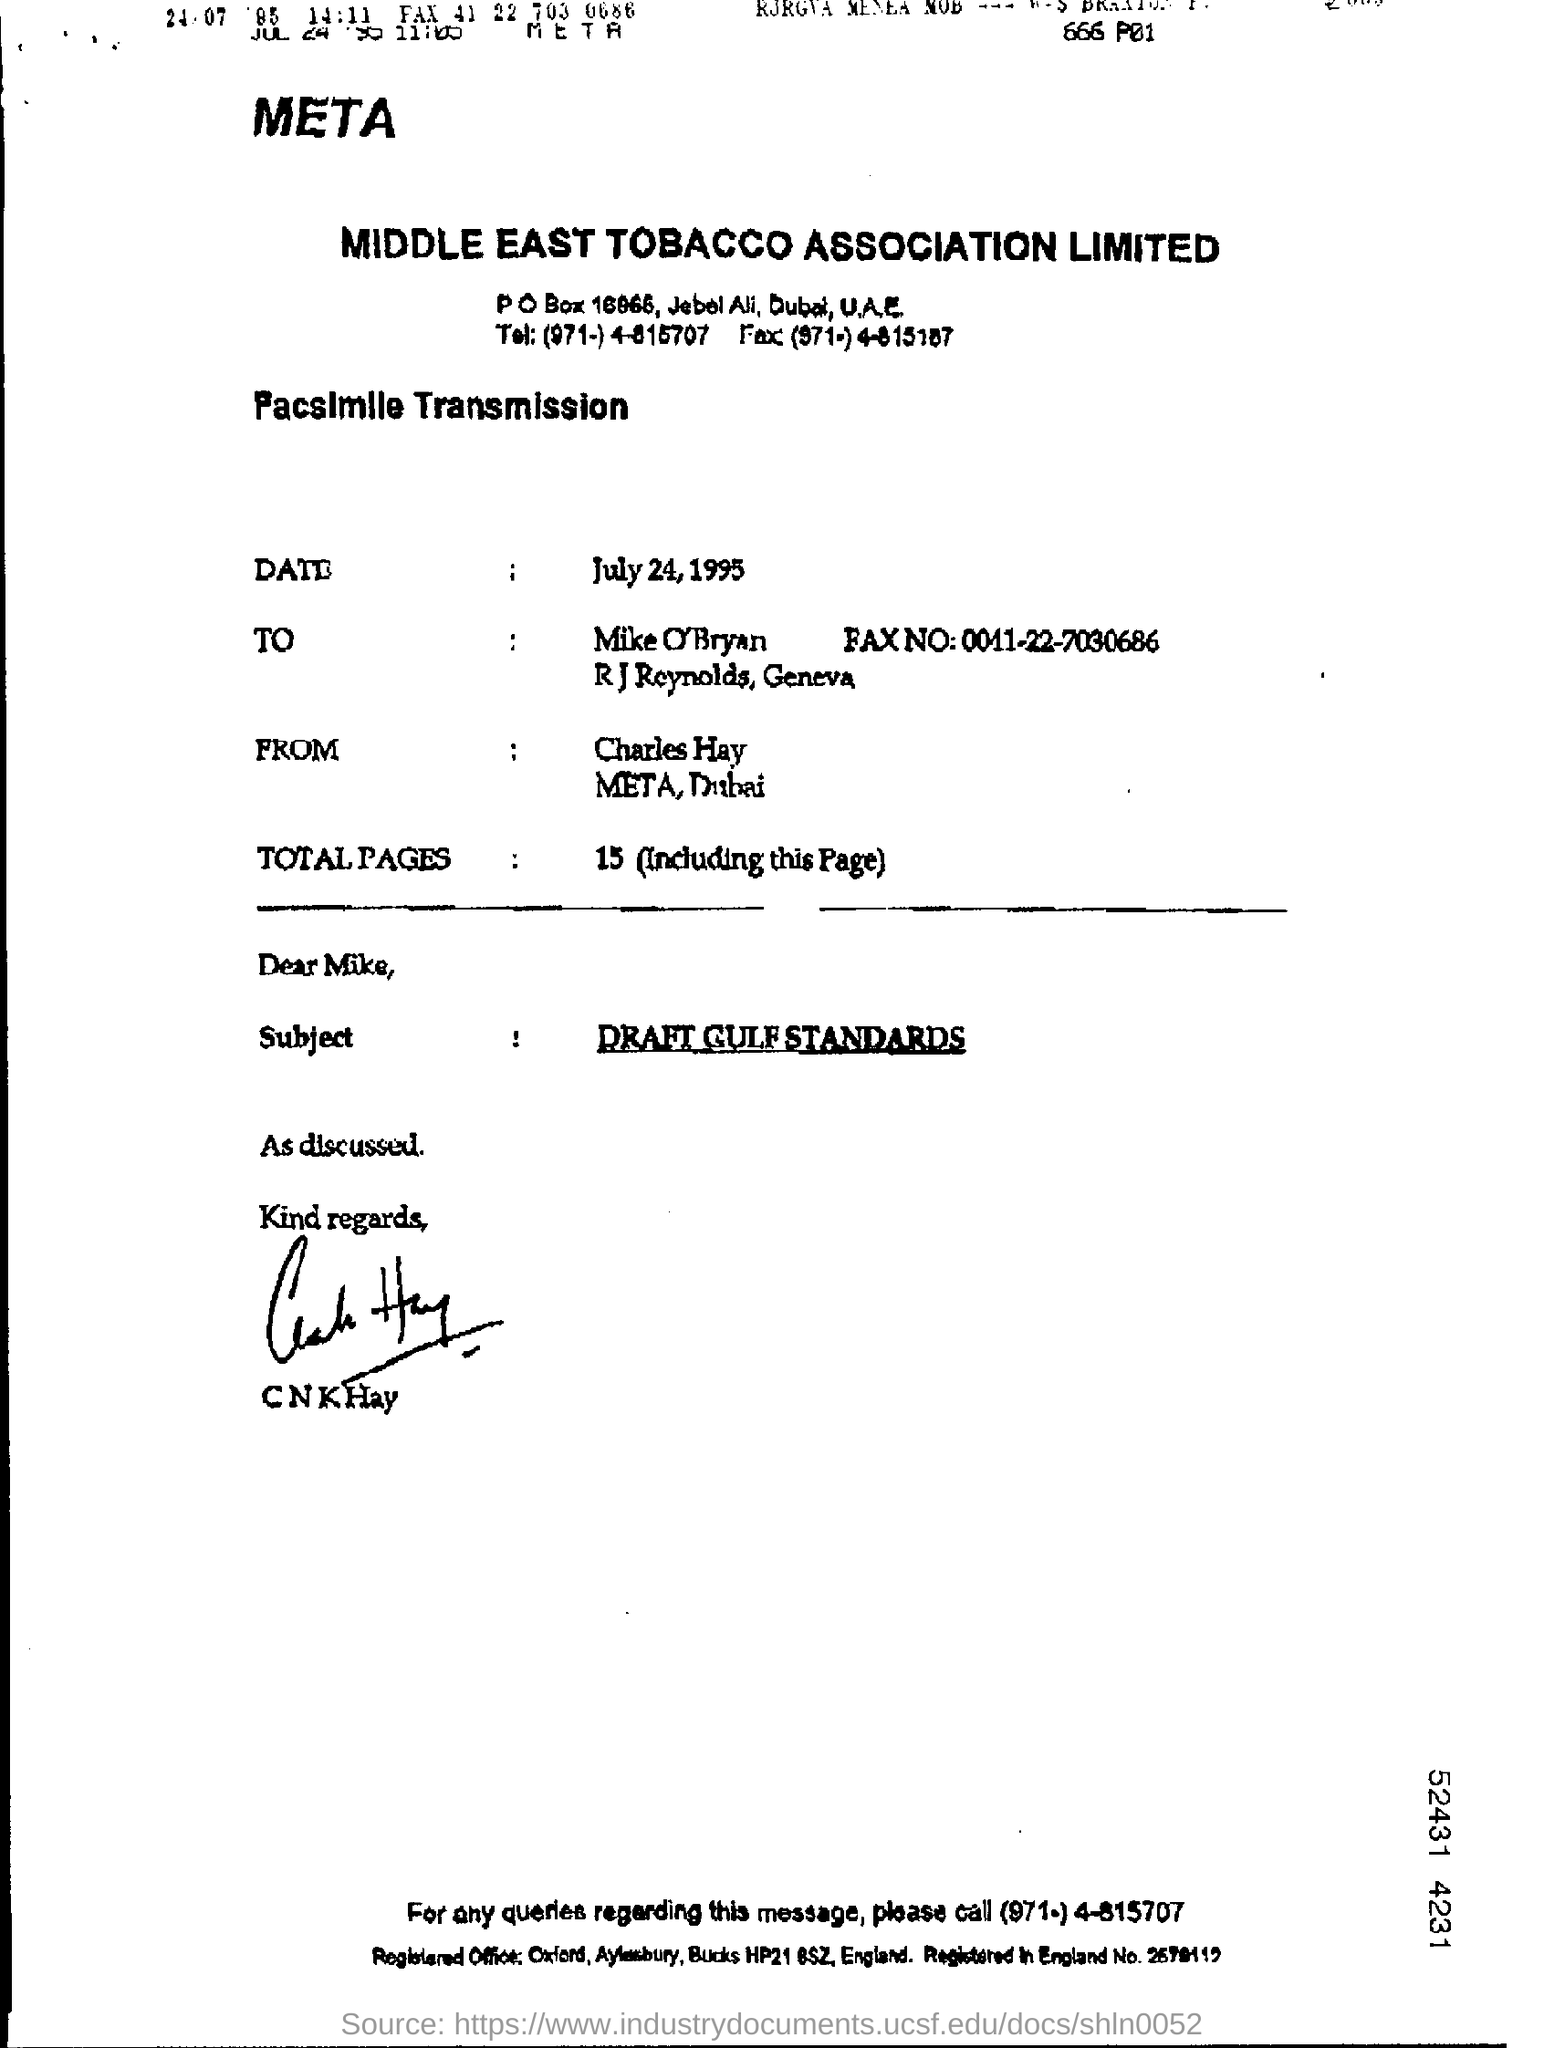Highlight a few significant elements in this photo. The subject of the facsimile transmission is the draft Gulf standards. 